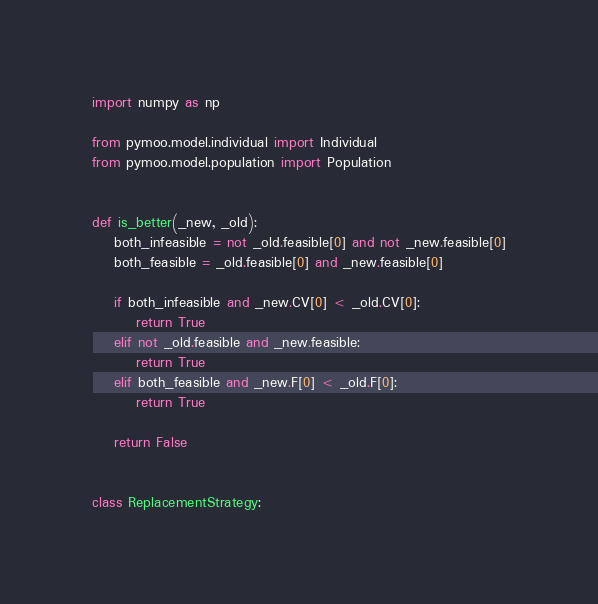Convert code to text. <code><loc_0><loc_0><loc_500><loc_500><_Python_>import numpy as np

from pymoo.model.individual import Individual
from pymoo.model.population import Population


def is_better(_new, _old):
    both_infeasible = not _old.feasible[0] and not _new.feasible[0]
    both_feasible = _old.feasible[0] and _new.feasible[0]

    if both_infeasible and _new.CV[0] < _old.CV[0]:
        return True
    elif not _old.feasible and _new.feasible:
        return True
    elif both_feasible and _new.F[0] < _old.F[0]:
        return True

    return False


class ReplacementStrategy:
</code> 